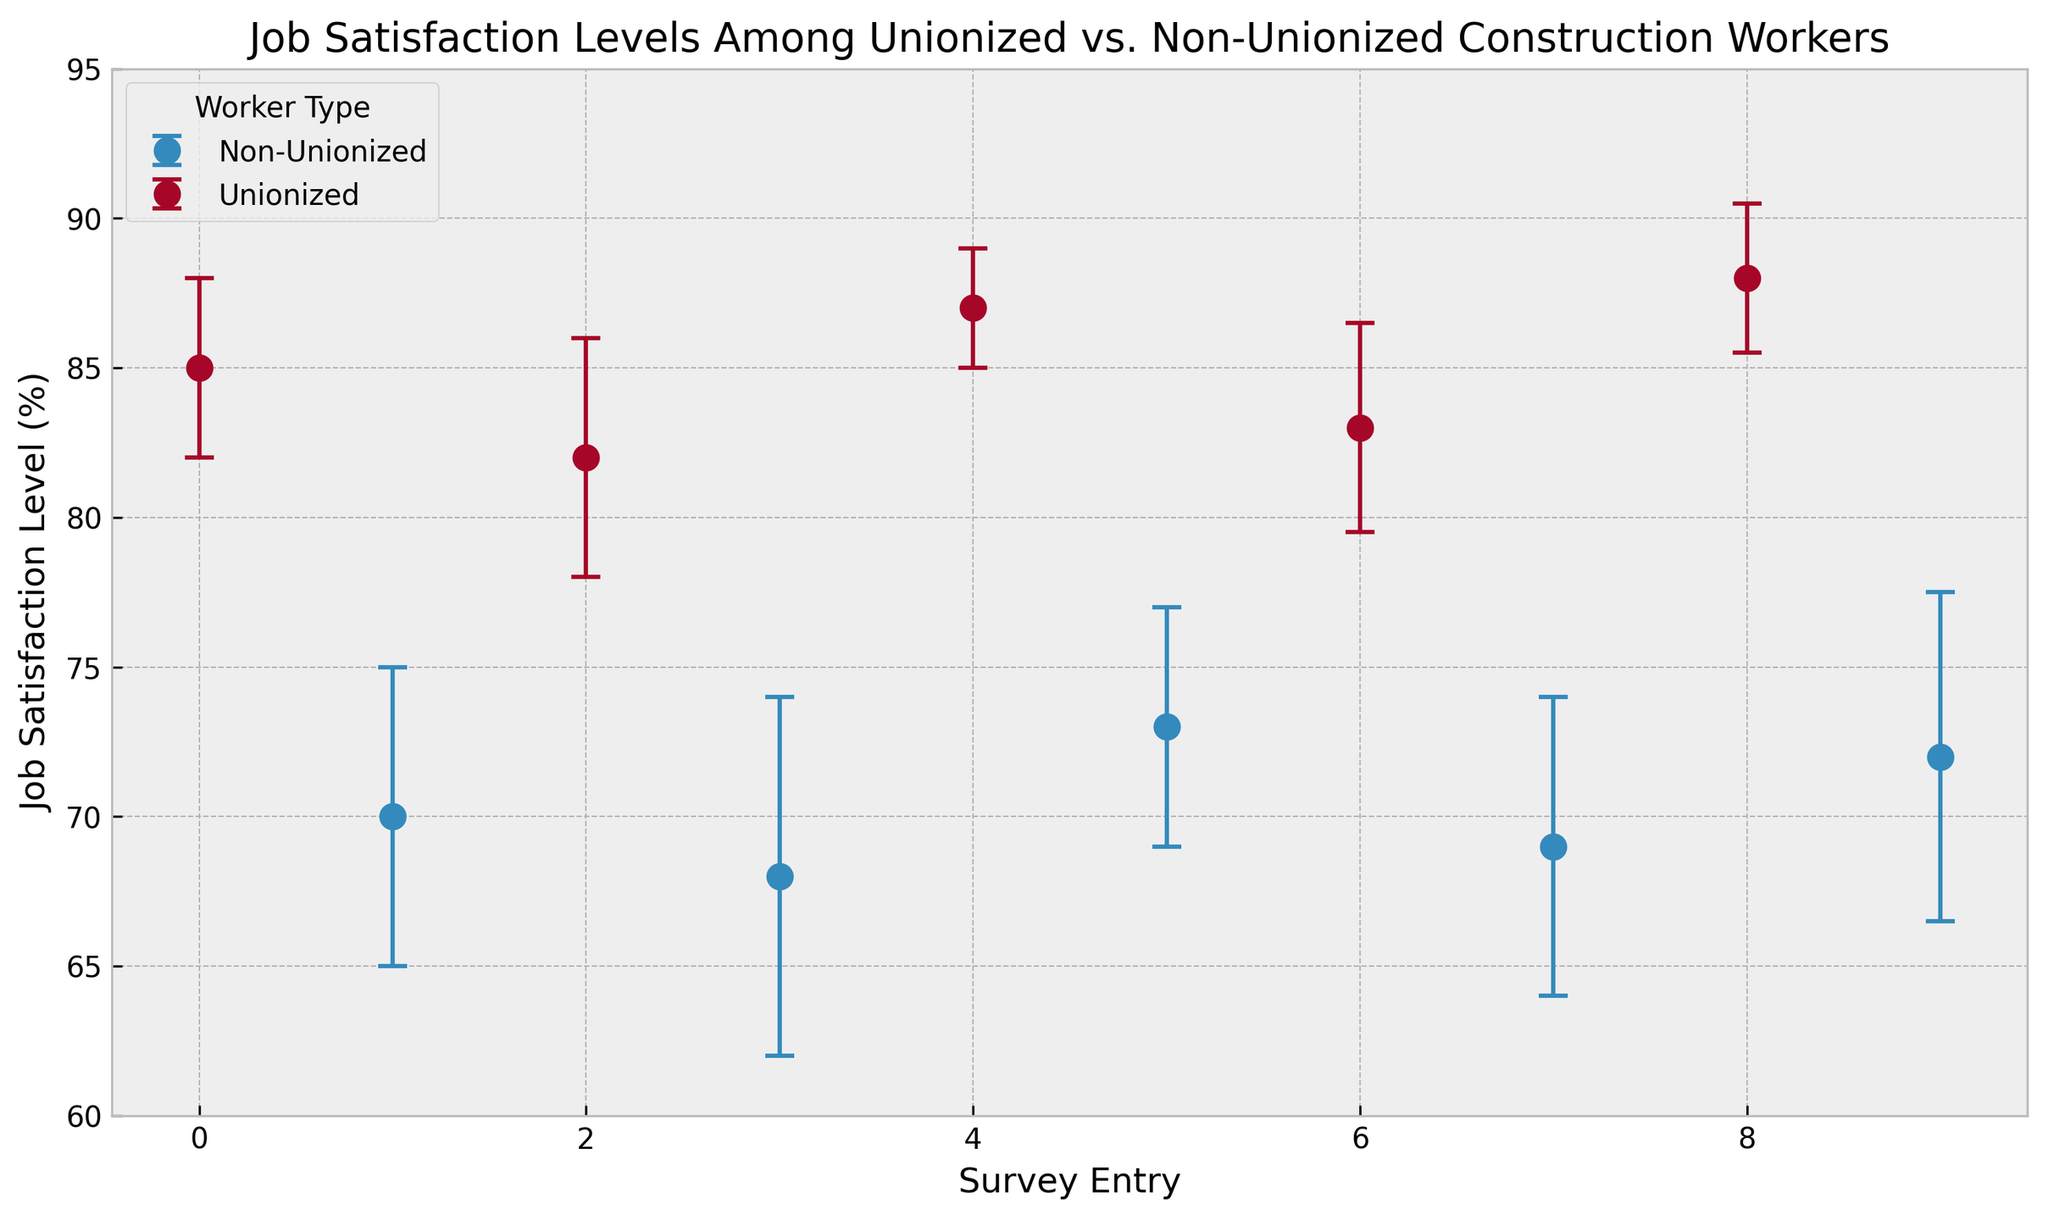What are the average job satisfaction levels for unionized and non-unionized workers? To find the average job satisfaction levels, sum the satisfaction levels for each group, then divide by the number of data points. For unionized: (85 + 82 + 87 + 83 + 88)/5 = 425/5 = 85%. For non-unionized: (70 + 68 + 73 + 69 + 72)/5 = 352/5 = 70.4%.
Answer: Unionized: 85%, Non-Unionized: 70.4% Which group has the highest individual job satisfaction level recorded in the figure? Look for the highest job satisfaction level percentage among all entries in the figure. The highest is 88% for the unionized group.
Answer: Unionized Which group has a wider margin of error on average? Calculate the average margin of error for both groups. For unionized: (3 + 4 + 2 + 3.5 + 2.5)/5 = 15/5 = 3%. For non-unionized: (5 + 6 + 4 + 5 + 5.5)/5 = 25.5/5 = 5.1%. Non-unionized has a wider margin of error on average.
Answer: Non-unionized What is the difference between the highest and lowest job satisfaction levels among unionized workers? Identify the highest and lowest satisfaction levels among unionized workers and calculate the difference: 88% - 82% = 6%.
Answer: 6% Are there any overlapping error bars between unionized and non-unionized worker satisfaction levels? Check the range of error bars for overlap. If the highest possible satisfaction from a lower mean overlaps with the lowest possible satisfaction from a higher mean, they overlap. Non-unionized ranges from 62% to 78%, and unionized ranges from 79.5% to 90.5%. There is no overlap.
Answer: No Compare the median satisfaction levels between unionized and non-unionized workers. Sort and find the middle value. For unionized: sorted levels are 82%, 83%, 85%, 87%, 88%; median is 85%. For non-unionized: sorted levels are 68%, 69%, 70%, 72%, 73%; median is 70%.
Answer: Unionized: 85%, Non-unionized: 70% 